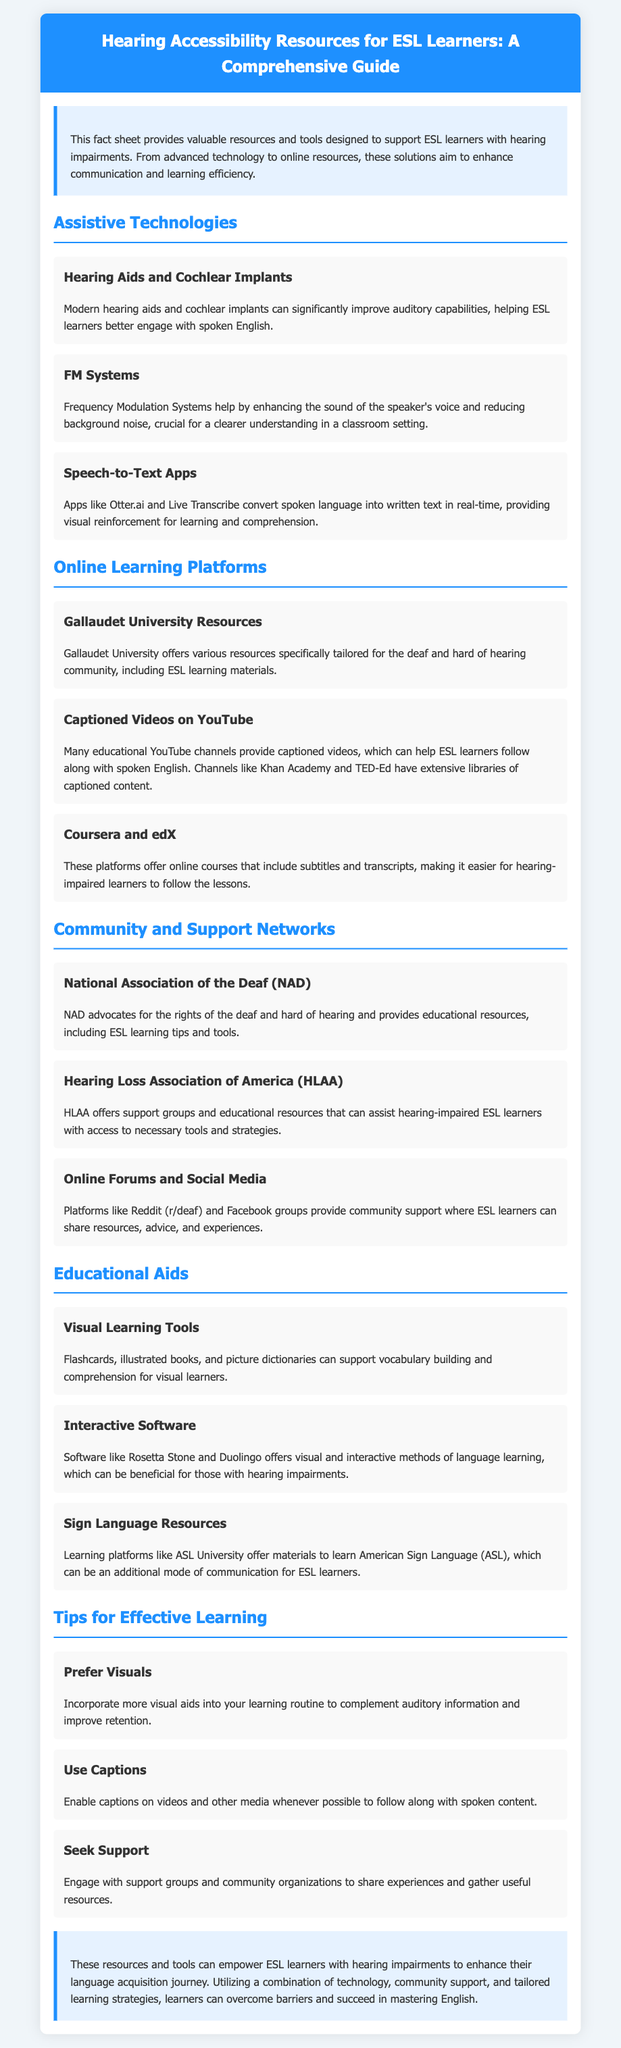What is the title of the guide? The title is clearly indicated in the header section of the document.
Answer: Hearing Accessibility Resources for ESL Learners: A Comprehensive Guide What type of systems help enhance the speaker's voice? FM systems are mentioned specifically for this purpose in the document under Assistive Technologies.
Answer: FM Systems Which university offers resources for the deaf and hard of hearing community? The document provides information on Gallaudet University, which focuses on this community.
Answer: Gallaudet University What organization advocates for the rights of the deaf? The National Association of the Deaf (NAD) is mentioned as an advocate for the deaf community.
Answer: National Association of the Deaf What learning tool is recommended for vocabulary building? The document mentions visual learning tools such as flashcards for supporting vocabulary building.
Answer: Visual Learning Tools How many online learning platforms are listed in the document? The document lists three platforms under Online Learning Platforms, requiring counting.
Answer: Three What type of resources do Speech-to-Text Apps provide? The document describes these apps as converting spoken language into written text in real-time.
Answer: Visual reinforcement What is one suggested tip for effective learning? The document gives various tips, one of which is to enable captions on videos.
Answer: Use Captions Which two software options are recommended for interactive language learning? The document lists Rosetta Stone and Duolingo for interactive learning methods.
Answer: Rosetta Stone and Duolingo 